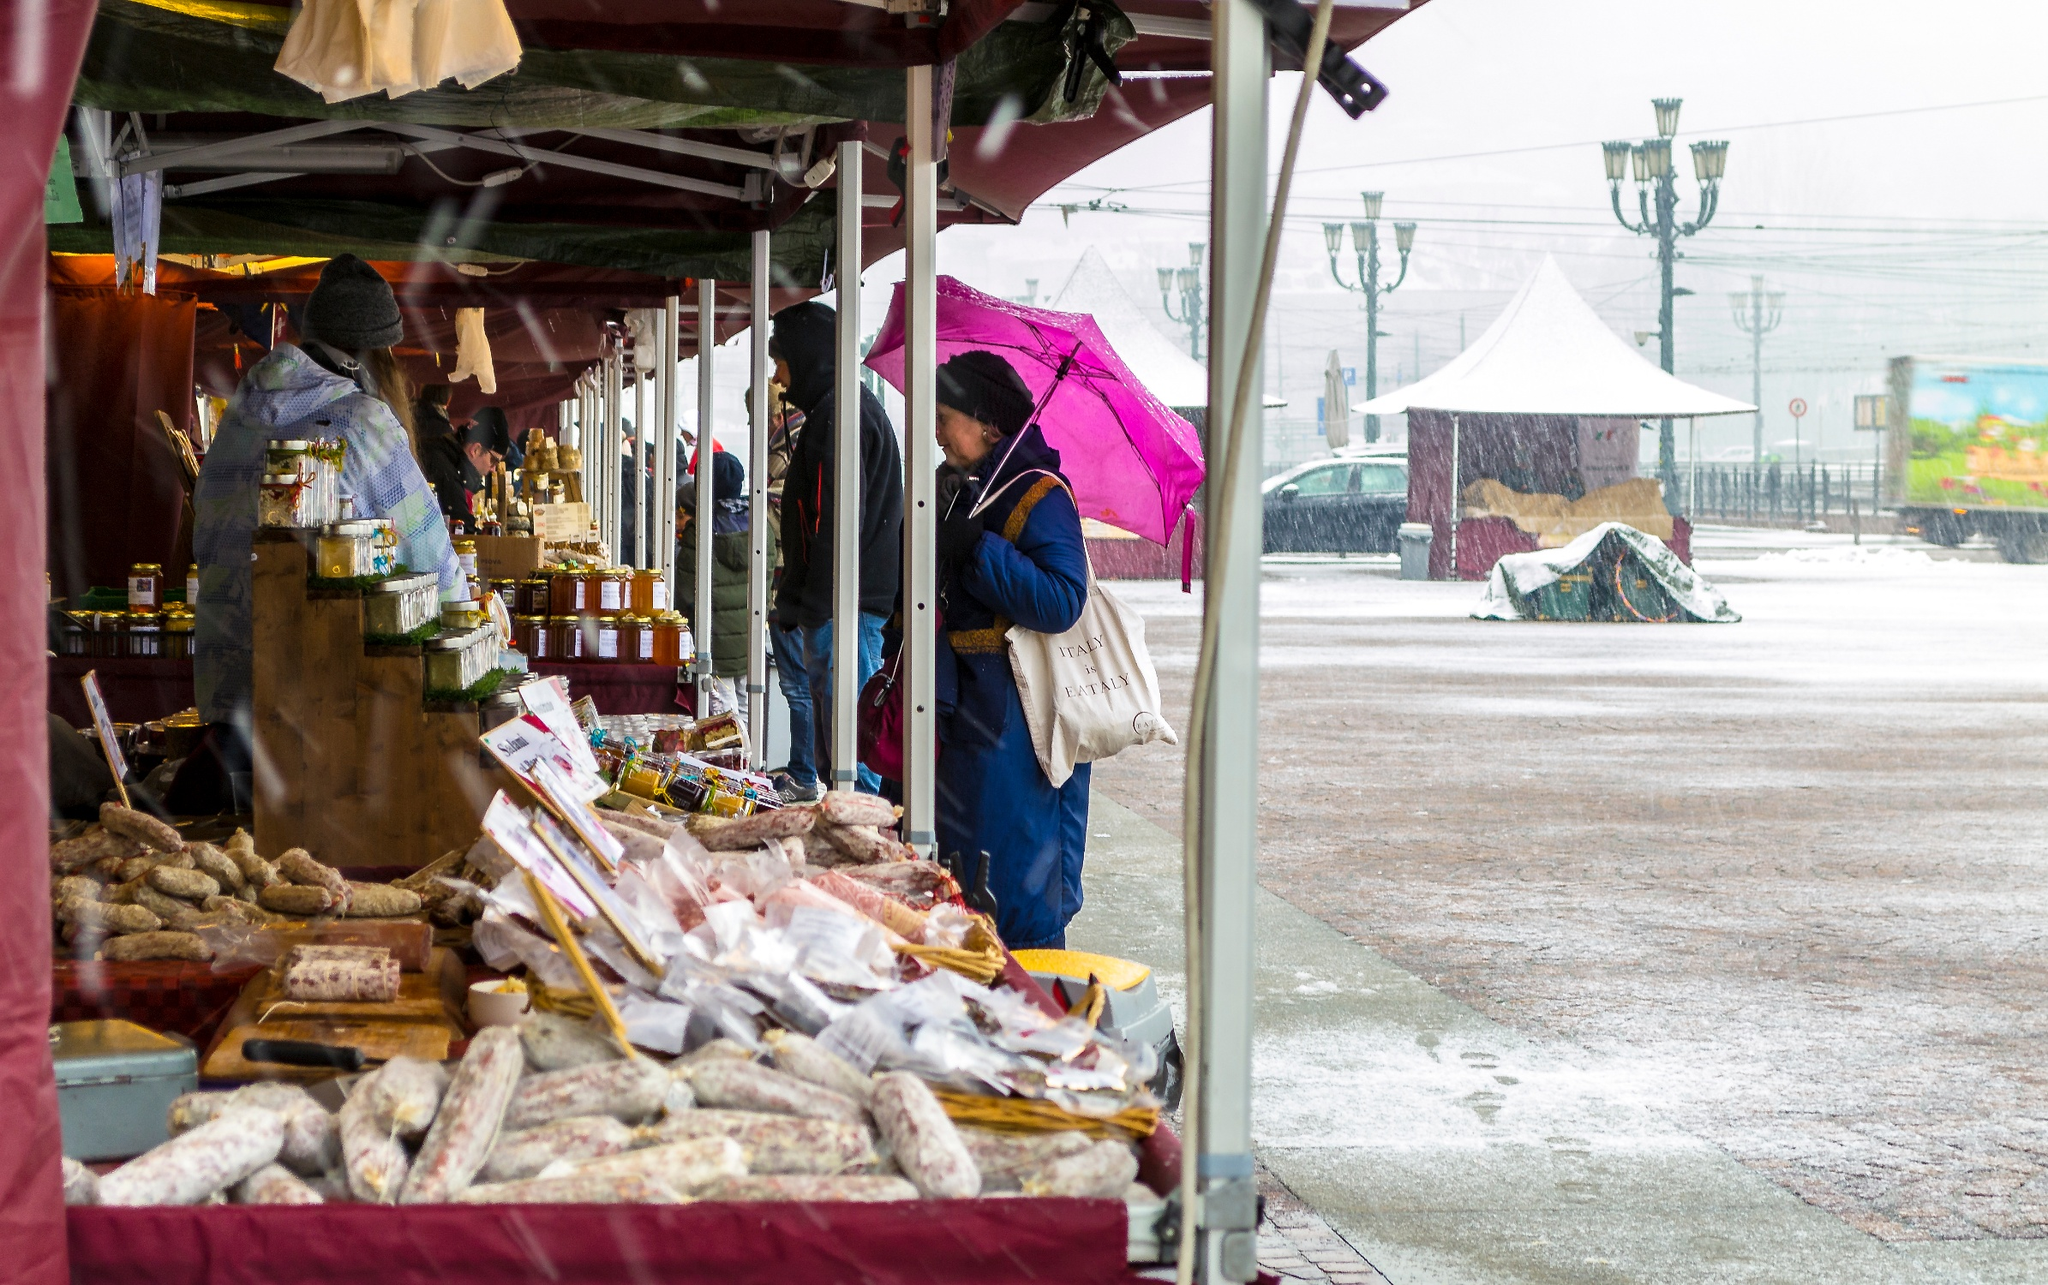What do you think is going on in this snapshot? The image captures a lively scene at an outdoor market on a rainy day. Under the protection of deep maroon canopies, a stall is abundantly filled with a variety of food items including assorted breads, sausages, and jars of preserved goods, all carefully arranged on a wooden counter. A vendor, seemingly focused on their trade, is seen engaging with a customer who brightens the scene with a vivid pink umbrella, in contrast to the otherwise overcast ambiance. The cobblestone street, glistening with raindrops, and a distinctive lamppost in the background enrich the setting, portraying a quaint, picturesque marketplace. It is important to note that the image does not feature any globally recognized landmarks, but it definitely conveys the charm of a local town market. 